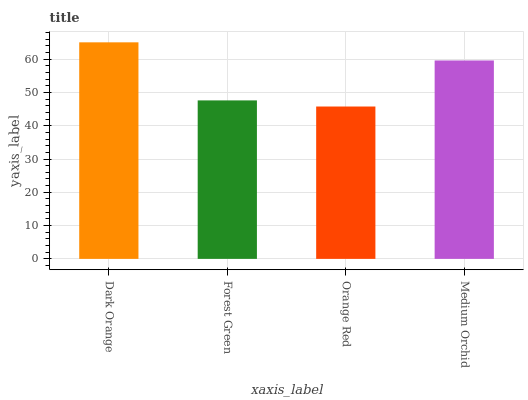Is Orange Red the minimum?
Answer yes or no. Yes. Is Dark Orange the maximum?
Answer yes or no. Yes. Is Forest Green the minimum?
Answer yes or no. No. Is Forest Green the maximum?
Answer yes or no. No. Is Dark Orange greater than Forest Green?
Answer yes or no. Yes. Is Forest Green less than Dark Orange?
Answer yes or no. Yes. Is Forest Green greater than Dark Orange?
Answer yes or no. No. Is Dark Orange less than Forest Green?
Answer yes or no. No. Is Medium Orchid the high median?
Answer yes or no. Yes. Is Forest Green the low median?
Answer yes or no. Yes. Is Dark Orange the high median?
Answer yes or no. No. Is Dark Orange the low median?
Answer yes or no. No. 